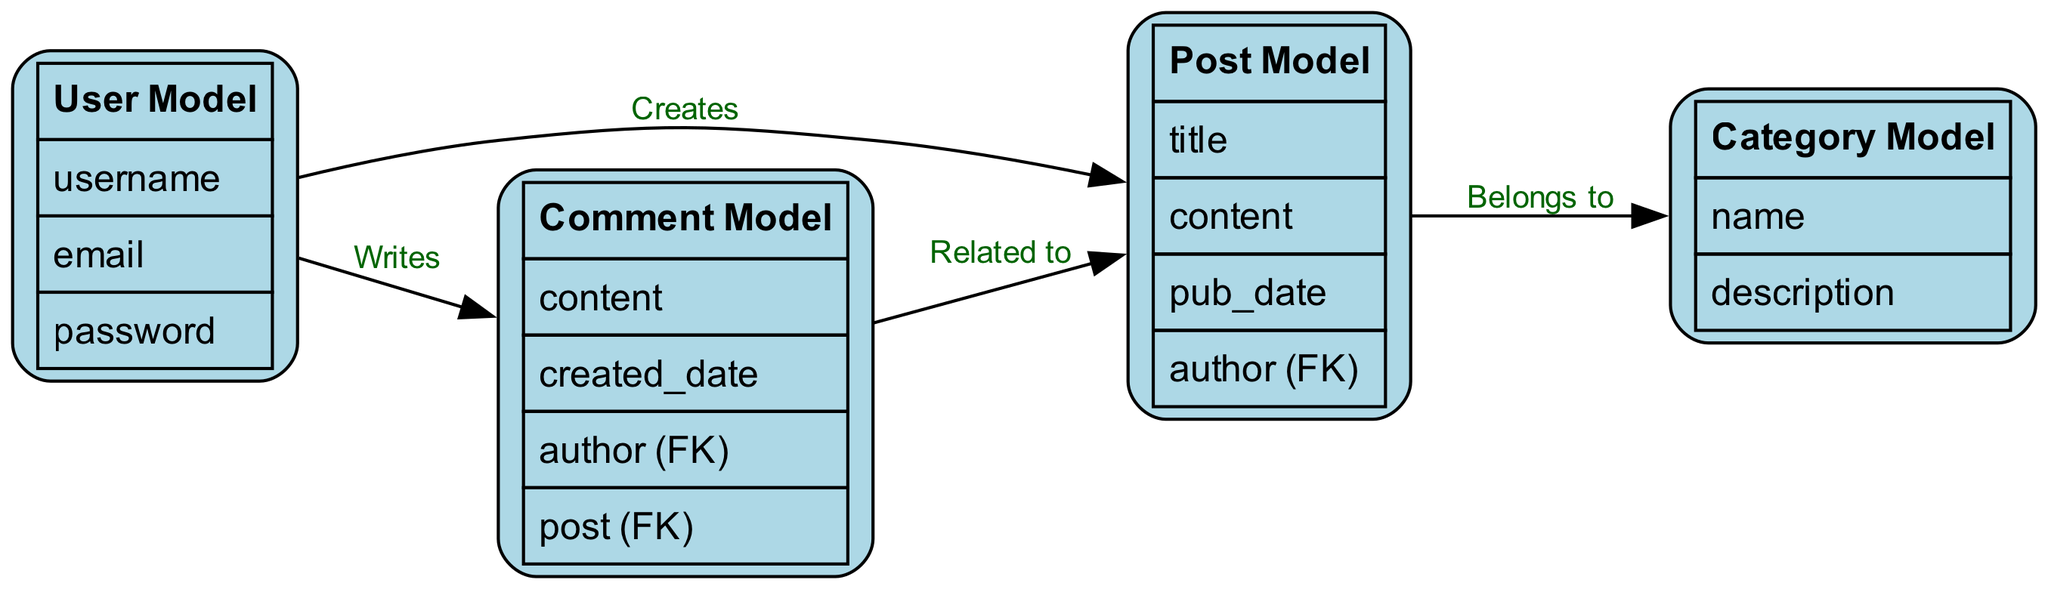What is the number of nodes in the diagram? The diagram consists of four different nodes representing the User Model, Post Model, Category Model, and Comment Model. By counting each of these unique models, we find the total is four.
Answer: 4 What is the relationship between the User Model and the Post Model? The User Model has a relationship labeled "Creates" with the Post Model. This indicates that users have the capability to create posts in the blog application.
Answer: Creates Which model has the attribute 'pub_date'? Looking at the attributes associated with each model, the 'pub_date' is listed under the Post Model. This identifies when a post is published.
Answer: Post Model How many edges are there in the diagram? Counting the connections in the edges section, we find there are four edges indicating relations between the models.
Answer: 4 Which model does the Comment Model relate to? The Comment Model is related to the Post Model through the relationship labeled "Related to." This indicates that comments are specifically linked to posts.
Answer: Post Model What attributes does the Category Model have? The Category Model attributes are explicitly listed in the attributes section as 'name' and 'description.' Thus, these are the two attributes defining the category in the blog.
Answer: name, description Who is the author of the Comment Model? The Comment Model includes an attribute for 'author (FK)', indicating that the author of a comment is a foreign key that references the User Model. This shows that comments are authored by users.
Answer: User Model Which model does the Post Model belong to? The diagram depicts that the Post Model has a relationship labeled "Belongs to" with the Category Model, indicating that each post is categorized under a specific category.
Answer: Category Model What is the attribute 'content' associated with in the User Model and Comment Model? The 'content' attribute in the diagram appears in the Comment Model, indicating the text of the comment being made, while the User Model does not directly use this attribute.
Answer: Comment Model 